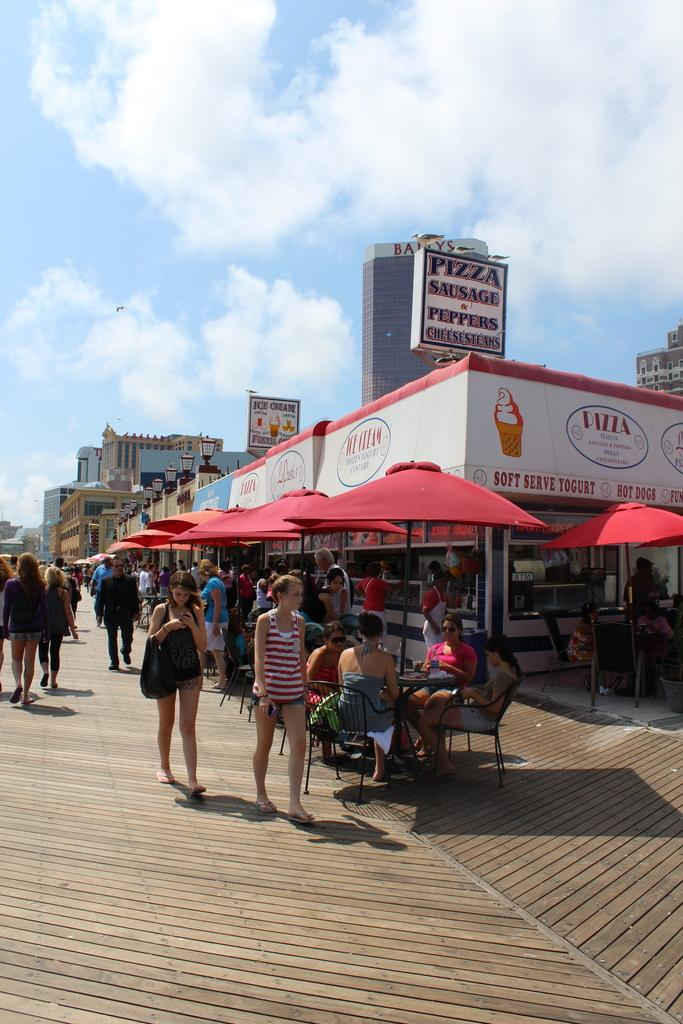What type of structures are present in the image? There are buildings and stalls in the image. Where are the buildings and stalls located? The buildings and stalls are in the center of the image. Are there any people visible in the image? Yes, there are people in the image. Where are the people located in the image? The people are on the left side of the image. What can be inferred about the setting of the image? The image appears to be a roadside view. What type of dress is the camera wearing in the image? There is no camera present in the image, let alone one wearing a dress. 